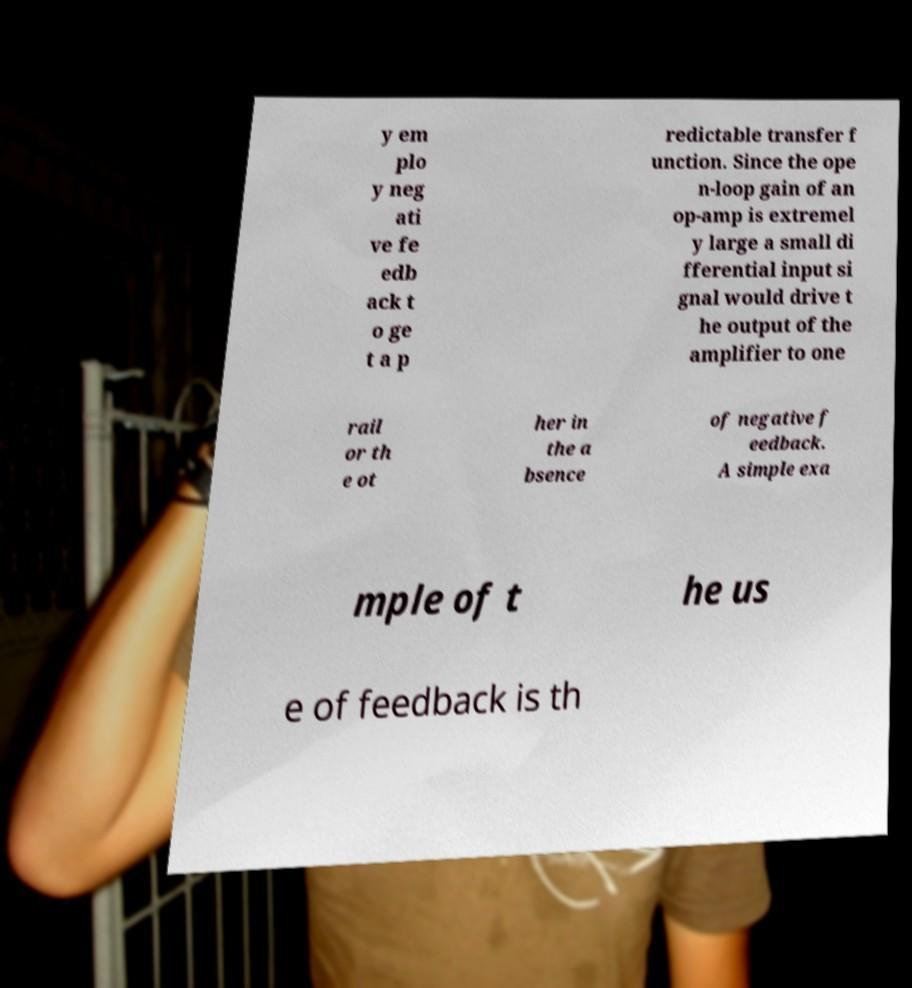Can you accurately transcribe the text from the provided image for me? y em plo y neg ati ve fe edb ack t o ge t a p redictable transfer f unction. Since the ope n-loop gain of an op-amp is extremel y large a small di fferential input si gnal would drive t he output of the amplifier to one rail or th e ot her in the a bsence of negative f eedback. A simple exa mple of t he us e of feedback is th 